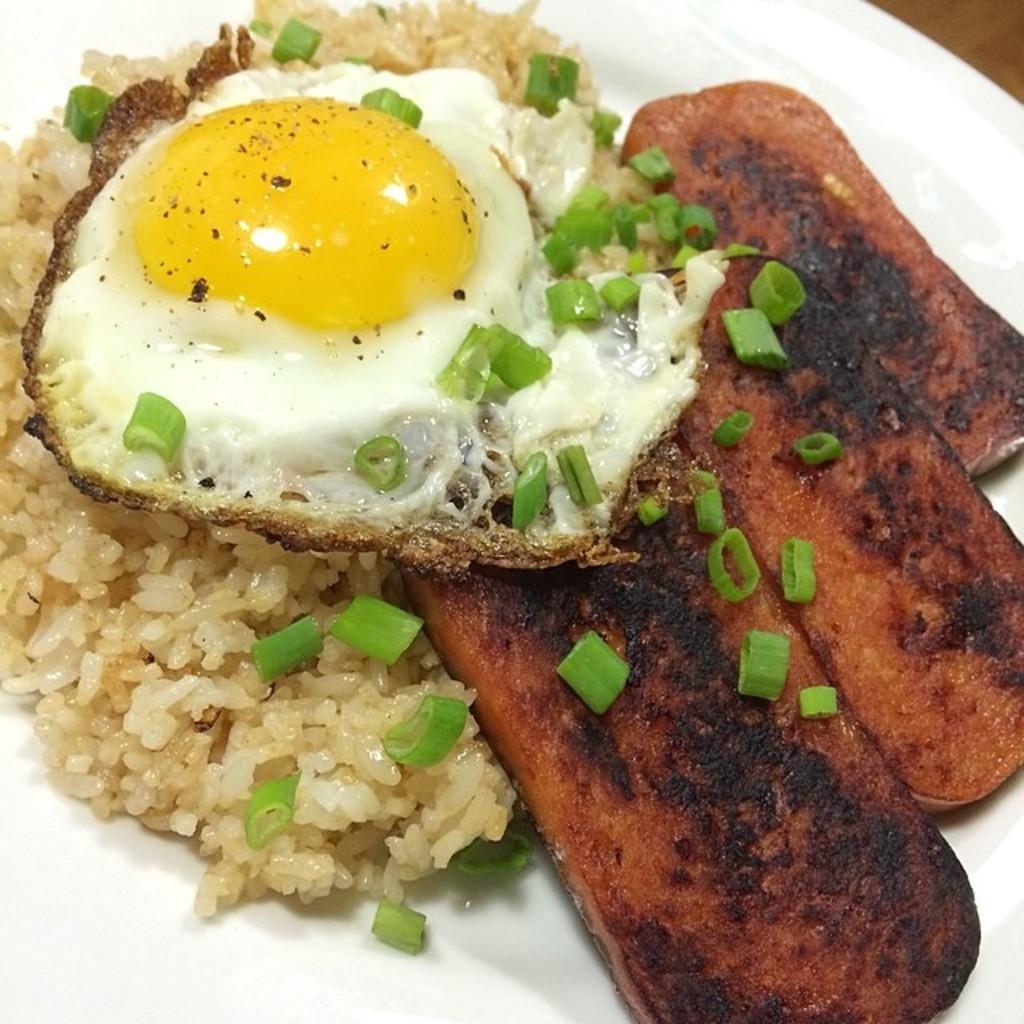In one or two sentences, can you explain what this image depicts? The picture consists of a plate on a table. On the plate where is rice, omelette and meat. 